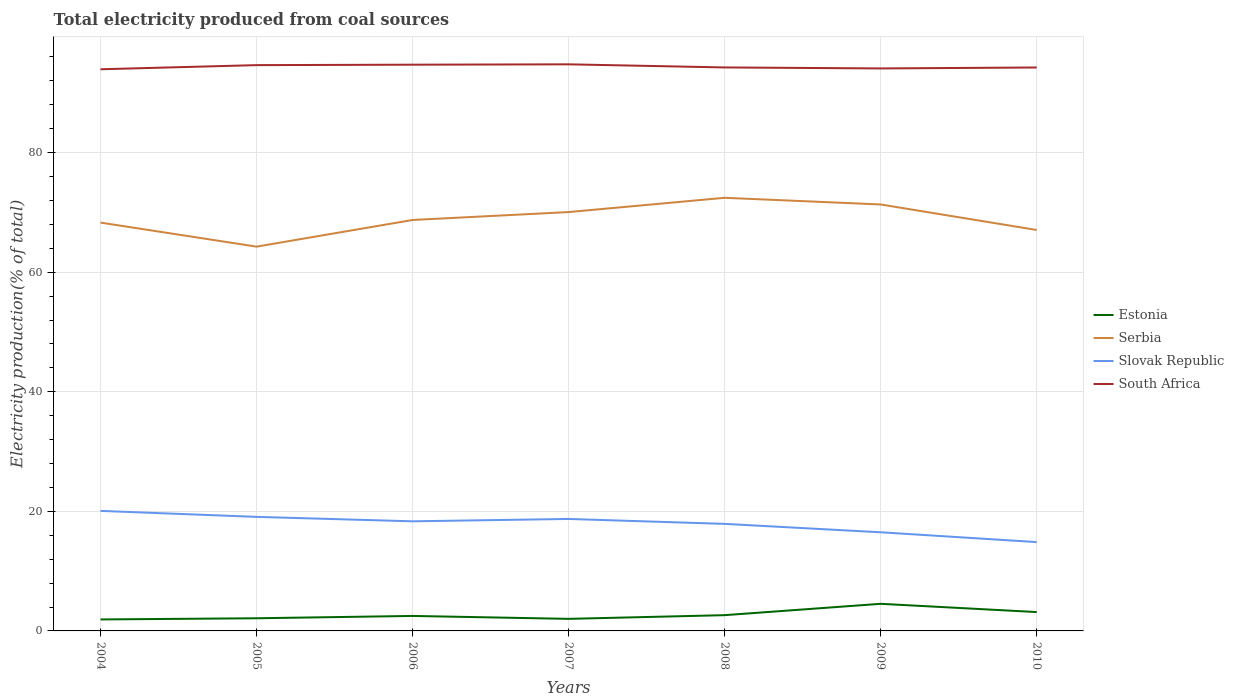How many different coloured lines are there?
Offer a very short reply. 4. Is the number of lines equal to the number of legend labels?
Your answer should be compact. Yes. Across all years, what is the maximum total electricity produced in Estonia?
Offer a terse response. 1.92. In which year was the total electricity produced in Slovak Republic maximum?
Make the answer very short. 2010. What is the total total electricity produced in Slovak Republic in the graph?
Make the answer very short. 1.35. What is the difference between the highest and the second highest total electricity produced in Slovak Republic?
Provide a succinct answer. 5.22. What is the difference between the highest and the lowest total electricity produced in Serbia?
Make the answer very short. 3. Is the total electricity produced in Serbia strictly greater than the total electricity produced in South Africa over the years?
Give a very brief answer. Yes. How many lines are there?
Make the answer very short. 4. How many years are there in the graph?
Ensure brevity in your answer.  7. Are the values on the major ticks of Y-axis written in scientific E-notation?
Your answer should be compact. No. Does the graph contain any zero values?
Make the answer very short. No. Where does the legend appear in the graph?
Offer a terse response. Center right. What is the title of the graph?
Ensure brevity in your answer.  Total electricity produced from coal sources. Does "Timor-Leste" appear as one of the legend labels in the graph?
Your response must be concise. No. What is the label or title of the X-axis?
Ensure brevity in your answer.  Years. What is the Electricity production(% of total) of Estonia in 2004?
Your answer should be very brief. 1.92. What is the Electricity production(% of total) of Serbia in 2004?
Your answer should be compact. 68.29. What is the Electricity production(% of total) of Slovak Republic in 2004?
Offer a very short reply. 20.08. What is the Electricity production(% of total) in South Africa in 2004?
Your response must be concise. 93.93. What is the Electricity production(% of total) in Estonia in 2005?
Provide a succinct answer. 2.12. What is the Electricity production(% of total) of Serbia in 2005?
Provide a succinct answer. 64.27. What is the Electricity production(% of total) of Slovak Republic in 2005?
Your answer should be very brief. 19.07. What is the Electricity production(% of total) in South Africa in 2005?
Give a very brief answer. 94.63. What is the Electricity production(% of total) in Estonia in 2006?
Your answer should be very brief. 2.51. What is the Electricity production(% of total) of Serbia in 2006?
Offer a terse response. 68.73. What is the Electricity production(% of total) in Slovak Republic in 2006?
Offer a terse response. 18.33. What is the Electricity production(% of total) in South Africa in 2006?
Provide a short and direct response. 94.7. What is the Electricity production(% of total) of Estonia in 2007?
Your response must be concise. 2.02. What is the Electricity production(% of total) of Serbia in 2007?
Keep it short and to the point. 70.05. What is the Electricity production(% of total) in Slovak Republic in 2007?
Ensure brevity in your answer.  18.73. What is the Electricity production(% of total) of South Africa in 2007?
Your answer should be very brief. 94.76. What is the Electricity production(% of total) in Estonia in 2008?
Give a very brief answer. 2.64. What is the Electricity production(% of total) of Serbia in 2008?
Keep it short and to the point. 72.44. What is the Electricity production(% of total) in Slovak Republic in 2008?
Provide a short and direct response. 17.9. What is the Electricity production(% of total) in South Africa in 2008?
Your answer should be compact. 94.24. What is the Electricity production(% of total) of Estonia in 2009?
Keep it short and to the point. 4.53. What is the Electricity production(% of total) in Serbia in 2009?
Provide a short and direct response. 71.32. What is the Electricity production(% of total) in Slovak Republic in 2009?
Your answer should be very brief. 16.5. What is the Electricity production(% of total) of South Africa in 2009?
Provide a succinct answer. 94.07. What is the Electricity production(% of total) of Estonia in 2010?
Your answer should be very brief. 3.15. What is the Electricity production(% of total) in Serbia in 2010?
Provide a succinct answer. 67.06. What is the Electricity production(% of total) of Slovak Republic in 2010?
Give a very brief answer. 14.86. What is the Electricity production(% of total) of South Africa in 2010?
Make the answer very short. 94.23. Across all years, what is the maximum Electricity production(% of total) in Estonia?
Give a very brief answer. 4.53. Across all years, what is the maximum Electricity production(% of total) of Serbia?
Your answer should be compact. 72.44. Across all years, what is the maximum Electricity production(% of total) in Slovak Republic?
Keep it short and to the point. 20.08. Across all years, what is the maximum Electricity production(% of total) of South Africa?
Your answer should be compact. 94.76. Across all years, what is the minimum Electricity production(% of total) in Estonia?
Offer a terse response. 1.92. Across all years, what is the minimum Electricity production(% of total) of Serbia?
Your response must be concise. 64.27. Across all years, what is the minimum Electricity production(% of total) of Slovak Republic?
Your response must be concise. 14.86. Across all years, what is the minimum Electricity production(% of total) of South Africa?
Your response must be concise. 93.93. What is the total Electricity production(% of total) in Estonia in the graph?
Offer a terse response. 18.89. What is the total Electricity production(% of total) in Serbia in the graph?
Provide a short and direct response. 482.16. What is the total Electricity production(% of total) of Slovak Republic in the graph?
Give a very brief answer. 125.46. What is the total Electricity production(% of total) in South Africa in the graph?
Ensure brevity in your answer.  660.56. What is the difference between the Electricity production(% of total) of Estonia in 2004 and that in 2005?
Ensure brevity in your answer.  -0.2. What is the difference between the Electricity production(% of total) of Serbia in 2004 and that in 2005?
Keep it short and to the point. 4.02. What is the difference between the Electricity production(% of total) in South Africa in 2004 and that in 2005?
Keep it short and to the point. -0.69. What is the difference between the Electricity production(% of total) of Estonia in 2004 and that in 2006?
Your answer should be very brief. -0.59. What is the difference between the Electricity production(% of total) in Serbia in 2004 and that in 2006?
Ensure brevity in your answer.  -0.44. What is the difference between the Electricity production(% of total) of Slovak Republic in 2004 and that in 2006?
Offer a very short reply. 1.74. What is the difference between the Electricity production(% of total) of South Africa in 2004 and that in 2006?
Ensure brevity in your answer.  -0.77. What is the difference between the Electricity production(% of total) of Estonia in 2004 and that in 2007?
Keep it short and to the point. -0.1. What is the difference between the Electricity production(% of total) of Serbia in 2004 and that in 2007?
Ensure brevity in your answer.  -1.76. What is the difference between the Electricity production(% of total) of Slovak Republic in 2004 and that in 2007?
Ensure brevity in your answer.  1.35. What is the difference between the Electricity production(% of total) in South Africa in 2004 and that in 2007?
Offer a terse response. -0.83. What is the difference between the Electricity production(% of total) in Estonia in 2004 and that in 2008?
Make the answer very short. -0.72. What is the difference between the Electricity production(% of total) of Serbia in 2004 and that in 2008?
Give a very brief answer. -4.15. What is the difference between the Electricity production(% of total) in Slovak Republic in 2004 and that in 2008?
Offer a terse response. 2.17. What is the difference between the Electricity production(% of total) in South Africa in 2004 and that in 2008?
Your answer should be very brief. -0.31. What is the difference between the Electricity production(% of total) in Estonia in 2004 and that in 2009?
Provide a short and direct response. -2.61. What is the difference between the Electricity production(% of total) of Serbia in 2004 and that in 2009?
Offer a very short reply. -3.03. What is the difference between the Electricity production(% of total) of Slovak Republic in 2004 and that in 2009?
Offer a very short reply. 3.58. What is the difference between the Electricity production(% of total) in South Africa in 2004 and that in 2009?
Provide a short and direct response. -0.14. What is the difference between the Electricity production(% of total) of Estonia in 2004 and that in 2010?
Make the answer very short. -1.23. What is the difference between the Electricity production(% of total) of Serbia in 2004 and that in 2010?
Give a very brief answer. 1.24. What is the difference between the Electricity production(% of total) in Slovak Republic in 2004 and that in 2010?
Offer a very short reply. 5.22. What is the difference between the Electricity production(% of total) of South Africa in 2004 and that in 2010?
Your response must be concise. -0.3. What is the difference between the Electricity production(% of total) of Estonia in 2005 and that in 2006?
Provide a succinct answer. -0.39. What is the difference between the Electricity production(% of total) of Serbia in 2005 and that in 2006?
Provide a succinct answer. -4.46. What is the difference between the Electricity production(% of total) of Slovak Republic in 2005 and that in 2006?
Your answer should be compact. 0.74. What is the difference between the Electricity production(% of total) in South Africa in 2005 and that in 2006?
Offer a terse response. -0.07. What is the difference between the Electricity production(% of total) of Estonia in 2005 and that in 2007?
Offer a terse response. 0.1. What is the difference between the Electricity production(% of total) in Serbia in 2005 and that in 2007?
Offer a terse response. -5.78. What is the difference between the Electricity production(% of total) of Slovak Republic in 2005 and that in 2007?
Your answer should be very brief. 0.35. What is the difference between the Electricity production(% of total) of South Africa in 2005 and that in 2007?
Your response must be concise. -0.13. What is the difference between the Electricity production(% of total) of Estonia in 2005 and that in 2008?
Your answer should be very brief. -0.52. What is the difference between the Electricity production(% of total) of Serbia in 2005 and that in 2008?
Offer a very short reply. -8.17. What is the difference between the Electricity production(% of total) of Slovak Republic in 2005 and that in 2008?
Make the answer very short. 1.17. What is the difference between the Electricity production(% of total) in South Africa in 2005 and that in 2008?
Keep it short and to the point. 0.39. What is the difference between the Electricity production(% of total) of Estonia in 2005 and that in 2009?
Offer a very short reply. -2.42. What is the difference between the Electricity production(% of total) in Serbia in 2005 and that in 2009?
Your response must be concise. -7.05. What is the difference between the Electricity production(% of total) in Slovak Republic in 2005 and that in 2009?
Provide a short and direct response. 2.58. What is the difference between the Electricity production(% of total) of South Africa in 2005 and that in 2009?
Offer a very short reply. 0.55. What is the difference between the Electricity production(% of total) in Estonia in 2005 and that in 2010?
Your response must be concise. -1.04. What is the difference between the Electricity production(% of total) in Serbia in 2005 and that in 2010?
Give a very brief answer. -2.78. What is the difference between the Electricity production(% of total) of Slovak Republic in 2005 and that in 2010?
Offer a very short reply. 4.22. What is the difference between the Electricity production(% of total) of South Africa in 2005 and that in 2010?
Provide a short and direct response. 0.4. What is the difference between the Electricity production(% of total) in Estonia in 2006 and that in 2007?
Provide a succinct answer. 0.49. What is the difference between the Electricity production(% of total) in Serbia in 2006 and that in 2007?
Ensure brevity in your answer.  -1.32. What is the difference between the Electricity production(% of total) of Slovak Republic in 2006 and that in 2007?
Keep it short and to the point. -0.39. What is the difference between the Electricity production(% of total) of South Africa in 2006 and that in 2007?
Keep it short and to the point. -0.06. What is the difference between the Electricity production(% of total) of Estonia in 2006 and that in 2008?
Offer a terse response. -0.13. What is the difference between the Electricity production(% of total) of Serbia in 2006 and that in 2008?
Offer a terse response. -3.71. What is the difference between the Electricity production(% of total) in Slovak Republic in 2006 and that in 2008?
Keep it short and to the point. 0.43. What is the difference between the Electricity production(% of total) in South Africa in 2006 and that in 2008?
Give a very brief answer. 0.46. What is the difference between the Electricity production(% of total) of Estonia in 2006 and that in 2009?
Offer a terse response. -2.03. What is the difference between the Electricity production(% of total) of Serbia in 2006 and that in 2009?
Ensure brevity in your answer.  -2.59. What is the difference between the Electricity production(% of total) of Slovak Republic in 2006 and that in 2009?
Provide a succinct answer. 1.83. What is the difference between the Electricity production(% of total) of South Africa in 2006 and that in 2009?
Offer a very short reply. 0.63. What is the difference between the Electricity production(% of total) in Estonia in 2006 and that in 2010?
Your response must be concise. -0.65. What is the difference between the Electricity production(% of total) of Serbia in 2006 and that in 2010?
Make the answer very short. 1.67. What is the difference between the Electricity production(% of total) of Slovak Republic in 2006 and that in 2010?
Provide a succinct answer. 3.48. What is the difference between the Electricity production(% of total) of South Africa in 2006 and that in 2010?
Make the answer very short. 0.47. What is the difference between the Electricity production(% of total) in Estonia in 2007 and that in 2008?
Give a very brief answer. -0.62. What is the difference between the Electricity production(% of total) in Serbia in 2007 and that in 2008?
Your answer should be compact. -2.39. What is the difference between the Electricity production(% of total) in Slovak Republic in 2007 and that in 2008?
Keep it short and to the point. 0.82. What is the difference between the Electricity production(% of total) of South Africa in 2007 and that in 2008?
Your answer should be very brief. 0.52. What is the difference between the Electricity production(% of total) in Estonia in 2007 and that in 2009?
Provide a succinct answer. -2.52. What is the difference between the Electricity production(% of total) of Serbia in 2007 and that in 2009?
Your answer should be very brief. -1.27. What is the difference between the Electricity production(% of total) of Slovak Republic in 2007 and that in 2009?
Give a very brief answer. 2.23. What is the difference between the Electricity production(% of total) in South Africa in 2007 and that in 2009?
Provide a succinct answer. 0.69. What is the difference between the Electricity production(% of total) of Estonia in 2007 and that in 2010?
Your answer should be very brief. -1.14. What is the difference between the Electricity production(% of total) of Serbia in 2007 and that in 2010?
Ensure brevity in your answer.  3. What is the difference between the Electricity production(% of total) in Slovak Republic in 2007 and that in 2010?
Provide a short and direct response. 3.87. What is the difference between the Electricity production(% of total) of South Africa in 2007 and that in 2010?
Give a very brief answer. 0.53. What is the difference between the Electricity production(% of total) in Estonia in 2008 and that in 2009?
Give a very brief answer. -1.9. What is the difference between the Electricity production(% of total) of Serbia in 2008 and that in 2009?
Your answer should be very brief. 1.12. What is the difference between the Electricity production(% of total) in Slovak Republic in 2008 and that in 2009?
Offer a very short reply. 1.41. What is the difference between the Electricity production(% of total) of South Africa in 2008 and that in 2009?
Provide a succinct answer. 0.17. What is the difference between the Electricity production(% of total) of Estonia in 2008 and that in 2010?
Give a very brief answer. -0.52. What is the difference between the Electricity production(% of total) in Serbia in 2008 and that in 2010?
Keep it short and to the point. 5.38. What is the difference between the Electricity production(% of total) of Slovak Republic in 2008 and that in 2010?
Keep it short and to the point. 3.05. What is the difference between the Electricity production(% of total) in South Africa in 2008 and that in 2010?
Give a very brief answer. 0.01. What is the difference between the Electricity production(% of total) of Estonia in 2009 and that in 2010?
Make the answer very short. 1.38. What is the difference between the Electricity production(% of total) in Serbia in 2009 and that in 2010?
Your response must be concise. 4.27. What is the difference between the Electricity production(% of total) of Slovak Republic in 2009 and that in 2010?
Provide a short and direct response. 1.64. What is the difference between the Electricity production(% of total) in South Africa in 2009 and that in 2010?
Ensure brevity in your answer.  -0.16. What is the difference between the Electricity production(% of total) in Estonia in 2004 and the Electricity production(% of total) in Serbia in 2005?
Provide a short and direct response. -62.35. What is the difference between the Electricity production(% of total) of Estonia in 2004 and the Electricity production(% of total) of Slovak Republic in 2005?
Provide a short and direct response. -17.15. What is the difference between the Electricity production(% of total) in Estonia in 2004 and the Electricity production(% of total) in South Africa in 2005?
Your answer should be compact. -92.7. What is the difference between the Electricity production(% of total) in Serbia in 2004 and the Electricity production(% of total) in Slovak Republic in 2005?
Offer a terse response. 49.22. What is the difference between the Electricity production(% of total) in Serbia in 2004 and the Electricity production(% of total) in South Africa in 2005?
Offer a terse response. -26.34. What is the difference between the Electricity production(% of total) of Slovak Republic in 2004 and the Electricity production(% of total) of South Africa in 2005?
Your response must be concise. -74.55. What is the difference between the Electricity production(% of total) of Estonia in 2004 and the Electricity production(% of total) of Serbia in 2006?
Your answer should be compact. -66.81. What is the difference between the Electricity production(% of total) in Estonia in 2004 and the Electricity production(% of total) in Slovak Republic in 2006?
Make the answer very short. -16.41. What is the difference between the Electricity production(% of total) of Estonia in 2004 and the Electricity production(% of total) of South Africa in 2006?
Ensure brevity in your answer.  -92.78. What is the difference between the Electricity production(% of total) of Serbia in 2004 and the Electricity production(% of total) of Slovak Republic in 2006?
Keep it short and to the point. 49.96. What is the difference between the Electricity production(% of total) of Serbia in 2004 and the Electricity production(% of total) of South Africa in 2006?
Keep it short and to the point. -26.41. What is the difference between the Electricity production(% of total) of Slovak Republic in 2004 and the Electricity production(% of total) of South Africa in 2006?
Ensure brevity in your answer.  -74.62. What is the difference between the Electricity production(% of total) of Estonia in 2004 and the Electricity production(% of total) of Serbia in 2007?
Ensure brevity in your answer.  -68.13. What is the difference between the Electricity production(% of total) in Estonia in 2004 and the Electricity production(% of total) in Slovak Republic in 2007?
Keep it short and to the point. -16.8. What is the difference between the Electricity production(% of total) in Estonia in 2004 and the Electricity production(% of total) in South Africa in 2007?
Provide a succinct answer. -92.84. What is the difference between the Electricity production(% of total) in Serbia in 2004 and the Electricity production(% of total) in Slovak Republic in 2007?
Your response must be concise. 49.56. What is the difference between the Electricity production(% of total) of Serbia in 2004 and the Electricity production(% of total) of South Africa in 2007?
Keep it short and to the point. -26.47. What is the difference between the Electricity production(% of total) in Slovak Republic in 2004 and the Electricity production(% of total) in South Africa in 2007?
Your answer should be very brief. -74.68. What is the difference between the Electricity production(% of total) in Estonia in 2004 and the Electricity production(% of total) in Serbia in 2008?
Your answer should be very brief. -70.52. What is the difference between the Electricity production(% of total) of Estonia in 2004 and the Electricity production(% of total) of Slovak Republic in 2008?
Ensure brevity in your answer.  -15.98. What is the difference between the Electricity production(% of total) in Estonia in 2004 and the Electricity production(% of total) in South Africa in 2008?
Offer a very short reply. -92.32. What is the difference between the Electricity production(% of total) of Serbia in 2004 and the Electricity production(% of total) of Slovak Republic in 2008?
Your answer should be very brief. 50.39. What is the difference between the Electricity production(% of total) of Serbia in 2004 and the Electricity production(% of total) of South Africa in 2008?
Your answer should be compact. -25.95. What is the difference between the Electricity production(% of total) of Slovak Republic in 2004 and the Electricity production(% of total) of South Africa in 2008?
Keep it short and to the point. -74.16. What is the difference between the Electricity production(% of total) in Estonia in 2004 and the Electricity production(% of total) in Serbia in 2009?
Keep it short and to the point. -69.4. What is the difference between the Electricity production(% of total) in Estonia in 2004 and the Electricity production(% of total) in Slovak Republic in 2009?
Provide a short and direct response. -14.58. What is the difference between the Electricity production(% of total) in Estonia in 2004 and the Electricity production(% of total) in South Africa in 2009?
Make the answer very short. -92.15. What is the difference between the Electricity production(% of total) of Serbia in 2004 and the Electricity production(% of total) of Slovak Republic in 2009?
Ensure brevity in your answer.  51.79. What is the difference between the Electricity production(% of total) of Serbia in 2004 and the Electricity production(% of total) of South Africa in 2009?
Provide a succinct answer. -25.78. What is the difference between the Electricity production(% of total) of Slovak Republic in 2004 and the Electricity production(% of total) of South Africa in 2009?
Give a very brief answer. -74. What is the difference between the Electricity production(% of total) in Estonia in 2004 and the Electricity production(% of total) in Serbia in 2010?
Give a very brief answer. -65.13. What is the difference between the Electricity production(% of total) of Estonia in 2004 and the Electricity production(% of total) of Slovak Republic in 2010?
Offer a very short reply. -12.93. What is the difference between the Electricity production(% of total) in Estonia in 2004 and the Electricity production(% of total) in South Africa in 2010?
Your response must be concise. -92.31. What is the difference between the Electricity production(% of total) of Serbia in 2004 and the Electricity production(% of total) of Slovak Republic in 2010?
Make the answer very short. 53.43. What is the difference between the Electricity production(% of total) in Serbia in 2004 and the Electricity production(% of total) in South Africa in 2010?
Your answer should be compact. -25.94. What is the difference between the Electricity production(% of total) of Slovak Republic in 2004 and the Electricity production(% of total) of South Africa in 2010?
Your answer should be very brief. -74.16. What is the difference between the Electricity production(% of total) in Estonia in 2005 and the Electricity production(% of total) in Serbia in 2006?
Provide a short and direct response. -66.61. What is the difference between the Electricity production(% of total) of Estonia in 2005 and the Electricity production(% of total) of Slovak Republic in 2006?
Ensure brevity in your answer.  -16.22. What is the difference between the Electricity production(% of total) of Estonia in 2005 and the Electricity production(% of total) of South Africa in 2006?
Ensure brevity in your answer.  -92.58. What is the difference between the Electricity production(% of total) of Serbia in 2005 and the Electricity production(% of total) of Slovak Republic in 2006?
Your response must be concise. 45.94. What is the difference between the Electricity production(% of total) of Serbia in 2005 and the Electricity production(% of total) of South Africa in 2006?
Provide a succinct answer. -30.43. What is the difference between the Electricity production(% of total) of Slovak Republic in 2005 and the Electricity production(% of total) of South Africa in 2006?
Offer a terse response. -75.63. What is the difference between the Electricity production(% of total) in Estonia in 2005 and the Electricity production(% of total) in Serbia in 2007?
Ensure brevity in your answer.  -67.94. What is the difference between the Electricity production(% of total) in Estonia in 2005 and the Electricity production(% of total) in Slovak Republic in 2007?
Make the answer very short. -16.61. What is the difference between the Electricity production(% of total) in Estonia in 2005 and the Electricity production(% of total) in South Africa in 2007?
Give a very brief answer. -92.64. What is the difference between the Electricity production(% of total) of Serbia in 2005 and the Electricity production(% of total) of Slovak Republic in 2007?
Keep it short and to the point. 45.54. What is the difference between the Electricity production(% of total) in Serbia in 2005 and the Electricity production(% of total) in South Africa in 2007?
Keep it short and to the point. -30.49. What is the difference between the Electricity production(% of total) in Slovak Republic in 2005 and the Electricity production(% of total) in South Africa in 2007?
Your answer should be very brief. -75.69. What is the difference between the Electricity production(% of total) of Estonia in 2005 and the Electricity production(% of total) of Serbia in 2008?
Provide a short and direct response. -70.32. What is the difference between the Electricity production(% of total) of Estonia in 2005 and the Electricity production(% of total) of Slovak Republic in 2008?
Keep it short and to the point. -15.79. What is the difference between the Electricity production(% of total) in Estonia in 2005 and the Electricity production(% of total) in South Africa in 2008?
Your response must be concise. -92.12. What is the difference between the Electricity production(% of total) in Serbia in 2005 and the Electricity production(% of total) in Slovak Republic in 2008?
Give a very brief answer. 46.37. What is the difference between the Electricity production(% of total) of Serbia in 2005 and the Electricity production(% of total) of South Africa in 2008?
Provide a short and direct response. -29.97. What is the difference between the Electricity production(% of total) of Slovak Republic in 2005 and the Electricity production(% of total) of South Africa in 2008?
Your answer should be very brief. -75.17. What is the difference between the Electricity production(% of total) of Estonia in 2005 and the Electricity production(% of total) of Serbia in 2009?
Your answer should be compact. -69.21. What is the difference between the Electricity production(% of total) in Estonia in 2005 and the Electricity production(% of total) in Slovak Republic in 2009?
Make the answer very short. -14.38. What is the difference between the Electricity production(% of total) in Estonia in 2005 and the Electricity production(% of total) in South Africa in 2009?
Make the answer very short. -91.96. What is the difference between the Electricity production(% of total) of Serbia in 2005 and the Electricity production(% of total) of Slovak Republic in 2009?
Ensure brevity in your answer.  47.77. What is the difference between the Electricity production(% of total) in Serbia in 2005 and the Electricity production(% of total) in South Africa in 2009?
Provide a succinct answer. -29.8. What is the difference between the Electricity production(% of total) in Slovak Republic in 2005 and the Electricity production(% of total) in South Africa in 2009?
Your answer should be very brief. -75. What is the difference between the Electricity production(% of total) in Estonia in 2005 and the Electricity production(% of total) in Serbia in 2010?
Ensure brevity in your answer.  -64.94. What is the difference between the Electricity production(% of total) of Estonia in 2005 and the Electricity production(% of total) of Slovak Republic in 2010?
Offer a very short reply. -12.74. What is the difference between the Electricity production(% of total) of Estonia in 2005 and the Electricity production(% of total) of South Africa in 2010?
Your response must be concise. -92.11. What is the difference between the Electricity production(% of total) of Serbia in 2005 and the Electricity production(% of total) of Slovak Republic in 2010?
Your response must be concise. 49.41. What is the difference between the Electricity production(% of total) in Serbia in 2005 and the Electricity production(% of total) in South Africa in 2010?
Give a very brief answer. -29.96. What is the difference between the Electricity production(% of total) in Slovak Republic in 2005 and the Electricity production(% of total) in South Africa in 2010?
Offer a very short reply. -75.16. What is the difference between the Electricity production(% of total) of Estonia in 2006 and the Electricity production(% of total) of Serbia in 2007?
Keep it short and to the point. -67.54. What is the difference between the Electricity production(% of total) in Estonia in 2006 and the Electricity production(% of total) in Slovak Republic in 2007?
Your answer should be very brief. -16.22. What is the difference between the Electricity production(% of total) in Estonia in 2006 and the Electricity production(% of total) in South Africa in 2007?
Give a very brief answer. -92.25. What is the difference between the Electricity production(% of total) in Serbia in 2006 and the Electricity production(% of total) in Slovak Republic in 2007?
Provide a short and direct response. 50. What is the difference between the Electricity production(% of total) in Serbia in 2006 and the Electricity production(% of total) in South Africa in 2007?
Your response must be concise. -26.03. What is the difference between the Electricity production(% of total) of Slovak Republic in 2006 and the Electricity production(% of total) of South Africa in 2007?
Provide a succinct answer. -76.43. What is the difference between the Electricity production(% of total) in Estonia in 2006 and the Electricity production(% of total) in Serbia in 2008?
Provide a succinct answer. -69.93. What is the difference between the Electricity production(% of total) in Estonia in 2006 and the Electricity production(% of total) in Slovak Republic in 2008?
Offer a very short reply. -15.4. What is the difference between the Electricity production(% of total) of Estonia in 2006 and the Electricity production(% of total) of South Africa in 2008?
Keep it short and to the point. -91.73. What is the difference between the Electricity production(% of total) in Serbia in 2006 and the Electricity production(% of total) in Slovak Republic in 2008?
Give a very brief answer. 50.83. What is the difference between the Electricity production(% of total) in Serbia in 2006 and the Electricity production(% of total) in South Africa in 2008?
Ensure brevity in your answer.  -25.51. What is the difference between the Electricity production(% of total) in Slovak Republic in 2006 and the Electricity production(% of total) in South Africa in 2008?
Your response must be concise. -75.91. What is the difference between the Electricity production(% of total) in Estonia in 2006 and the Electricity production(% of total) in Serbia in 2009?
Ensure brevity in your answer.  -68.81. What is the difference between the Electricity production(% of total) in Estonia in 2006 and the Electricity production(% of total) in Slovak Republic in 2009?
Ensure brevity in your answer.  -13.99. What is the difference between the Electricity production(% of total) in Estonia in 2006 and the Electricity production(% of total) in South Africa in 2009?
Give a very brief answer. -91.57. What is the difference between the Electricity production(% of total) of Serbia in 2006 and the Electricity production(% of total) of Slovak Republic in 2009?
Your answer should be compact. 52.23. What is the difference between the Electricity production(% of total) in Serbia in 2006 and the Electricity production(% of total) in South Africa in 2009?
Provide a succinct answer. -25.34. What is the difference between the Electricity production(% of total) of Slovak Republic in 2006 and the Electricity production(% of total) of South Africa in 2009?
Your answer should be very brief. -75.74. What is the difference between the Electricity production(% of total) in Estonia in 2006 and the Electricity production(% of total) in Serbia in 2010?
Your response must be concise. -64.55. What is the difference between the Electricity production(% of total) in Estonia in 2006 and the Electricity production(% of total) in Slovak Republic in 2010?
Your answer should be compact. -12.35. What is the difference between the Electricity production(% of total) in Estonia in 2006 and the Electricity production(% of total) in South Africa in 2010?
Give a very brief answer. -91.72. What is the difference between the Electricity production(% of total) of Serbia in 2006 and the Electricity production(% of total) of Slovak Republic in 2010?
Provide a succinct answer. 53.87. What is the difference between the Electricity production(% of total) in Serbia in 2006 and the Electricity production(% of total) in South Africa in 2010?
Provide a succinct answer. -25.5. What is the difference between the Electricity production(% of total) in Slovak Republic in 2006 and the Electricity production(% of total) in South Africa in 2010?
Your response must be concise. -75.9. What is the difference between the Electricity production(% of total) in Estonia in 2007 and the Electricity production(% of total) in Serbia in 2008?
Give a very brief answer. -70.42. What is the difference between the Electricity production(% of total) of Estonia in 2007 and the Electricity production(% of total) of Slovak Republic in 2008?
Your response must be concise. -15.89. What is the difference between the Electricity production(% of total) in Estonia in 2007 and the Electricity production(% of total) in South Africa in 2008?
Make the answer very short. -92.22. What is the difference between the Electricity production(% of total) in Serbia in 2007 and the Electricity production(% of total) in Slovak Republic in 2008?
Your response must be concise. 52.15. What is the difference between the Electricity production(% of total) in Serbia in 2007 and the Electricity production(% of total) in South Africa in 2008?
Make the answer very short. -24.19. What is the difference between the Electricity production(% of total) in Slovak Republic in 2007 and the Electricity production(% of total) in South Africa in 2008?
Keep it short and to the point. -75.51. What is the difference between the Electricity production(% of total) in Estonia in 2007 and the Electricity production(% of total) in Serbia in 2009?
Provide a succinct answer. -69.3. What is the difference between the Electricity production(% of total) in Estonia in 2007 and the Electricity production(% of total) in Slovak Republic in 2009?
Your answer should be compact. -14.48. What is the difference between the Electricity production(% of total) in Estonia in 2007 and the Electricity production(% of total) in South Africa in 2009?
Your answer should be very brief. -92.06. What is the difference between the Electricity production(% of total) of Serbia in 2007 and the Electricity production(% of total) of Slovak Republic in 2009?
Your answer should be compact. 53.55. What is the difference between the Electricity production(% of total) in Serbia in 2007 and the Electricity production(% of total) in South Africa in 2009?
Offer a terse response. -24.02. What is the difference between the Electricity production(% of total) of Slovak Republic in 2007 and the Electricity production(% of total) of South Africa in 2009?
Provide a succinct answer. -75.35. What is the difference between the Electricity production(% of total) in Estonia in 2007 and the Electricity production(% of total) in Serbia in 2010?
Provide a succinct answer. -65.04. What is the difference between the Electricity production(% of total) of Estonia in 2007 and the Electricity production(% of total) of Slovak Republic in 2010?
Keep it short and to the point. -12.84. What is the difference between the Electricity production(% of total) of Estonia in 2007 and the Electricity production(% of total) of South Africa in 2010?
Keep it short and to the point. -92.21. What is the difference between the Electricity production(% of total) in Serbia in 2007 and the Electricity production(% of total) in Slovak Republic in 2010?
Keep it short and to the point. 55.2. What is the difference between the Electricity production(% of total) of Serbia in 2007 and the Electricity production(% of total) of South Africa in 2010?
Provide a succinct answer. -24.18. What is the difference between the Electricity production(% of total) in Slovak Republic in 2007 and the Electricity production(% of total) in South Africa in 2010?
Provide a succinct answer. -75.51. What is the difference between the Electricity production(% of total) of Estonia in 2008 and the Electricity production(% of total) of Serbia in 2009?
Keep it short and to the point. -68.69. What is the difference between the Electricity production(% of total) of Estonia in 2008 and the Electricity production(% of total) of Slovak Republic in 2009?
Provide a succinct answer. -13.86. What is the difference between the Electricity production(% of total) of Estonia in 2008 and the Electricity production(% of total) of South Africa in 2009?
Make the answer very short. -91.44. What is the difference between the Electricity production(% of total) in Serbia in 2008 and the Electricity production(% of total) in Slovak Republic in 2009?
Ensure brevity in your answer.  55.94. What is the difference between the Electricity production(% of total) of Serbia in 2008 and the Electricity production(% of total) of South Africa in 2009?
Your answer should be very brief. -21.63. What is the difference between the Electricity production(% of total) of Slovak Republic in 2008 and the Electricity production(% of total) of South Africa in 2009?
Offer a terse response. -76.17. What is the difference between the Electricity production(% of total) in Estonia in 2008 and the Electricity production(% of total) in Serbia in 2010?
Your answer should be compact. -64.42. What is the difference between the Electricity production(% of total) of Estonia in 2008 and the Electricity production(% of total) of Slovak Republic in 2010?
Your answer should be very brief. -12.22. What is the difference between the Electricity production(% of total) of Estonia in 2008 and the Electricity production(% of total) of South Africa in 2010?
Your response must be concise. -91.59. What is the difference between the Electricity production(% of total) of Serbia in 2008 and the Electricity production(% of total) of Slovak Republic in 2010?
Your answer should be very brief. 57.58. What is the difference between the Electricity production(% of total) in Serbia in 2008 and the Electricity production(% of total) in South Africa in 2010?
Ensure brevity in your answer.  -21.79. What is the difference between the Electricity production(% of total) of Slovak Republic in 2008 and the Electricity production(% of total) of South Africa in 2010?
Offer a very short reply. -76.33. What is the difference between the Electricity production(% of total) of Estonia in 2009 and the Electricity production(% of total) of Serbia in 2010?
Your answer should be compact. -62.52. What is the difference between the Electricity production(% of total) of Estonia in 2009 and the Electricity production(% of total) of Slovak Republic in 2010?
Your response must be concise. -10.32. What is the difference between the Electricity production(% of total) in Estonia in 2009 and the Electricity production(% of total) in South Africa in 2010?
Provide a short and direct response. -89.7. What is the difference between the Electricity production(% of total) in Serbia in 2009 and the Electricity production(% of total) in Slovak Republic in 2010?
Your answer should be compact. 56.47. What is the difference between the Electricity production(% of total) in Serbia in 2009 and the Electricity production(% of total) in South Africa in 2010?
Your answer should be very brief. -22.91. What is the difference between the Electricity production(% of total) of Slovak Republic in 2009 and the Electricity production(% of total) of South Africa in 2010?
Give a very brief answer. -77.73. What is the average Electricity production(% of total) of Estonia per year?
Your answer should be very brief. 2.7. What is the average Electricity production(% of total) of Serbia per year?
Make the answer very short. 68.88. What is the average Electricity production(% of total) in Slovak Republic per year?
Make the answer very short. 17.92. What is the average Electricity production(% of total) of South Africa per year?
Provide a short and direct response. 94.37. In the year 2004, what is the difference between the Electricity production(% of total) in Estonia and Electricity production(% of total) in Serbia?
Provide a succinct answer. -66.37. In the year 2004, what is the difference between the Electricity production(% of total) of Estonia and Electricity production(% of total) of Slovak Republic?
Your answer should be compact. -18.15. In the year 2004, what is the difference between the Electricity production(% of total) in Estonia and Electricity production(% of total) in South Africa?
Offer a very short reply. -92.01. In the year 2004, what is the difference between the Electricity production(% of total) in Serbia and Electricity production(% of total) in Slovak Republic?
Make the answer very short. 48.22. In the year 2004, what is the difference between the Electricity production(% of total) in Serbia and Electricity production(% of total) in South Africa?
Your answer should be compact. -25.64. In the year 2004, what is the difference between the Electricity production(% of total) in Slovak Republic and Electricity production(% of total) in South Africa?
Your answer should be very brief. -73.86. In the year 2005, what is the difference between the Electricity production(% of total) in Estonia and Electricity production(% of total) in Serbia?
Give a very brief answer. -62.15. In the year 2005, what is the difference between the Electricity production(% of total) of Estonia and Electricity production(% of total) of Slovak Republic?
Give a very brief answer. -16.96. In the year 2005, what is the difference between the Electricity production(% of total) in Estonia and Electricity production(% of total) in South Africa?
Your response must be concise. -92.51. In the year 2005, what is the difference between the Electricity production(% of total) of Serbia and Electricity production(% of total) of Slovak Republic?
Give a very brief answer. 45.2. In the year 2005, what is the difference between the Electricity production(% of total) of Serbia and Electricity production(% of total) of South Africa?
Your response must be concise. -30.36. In the year 2005, what is the difference between the Electricity production(% of total) in Slovak Republic and Electricity production(% of total) in South Africa?
Your answer should be compact. -75.55. In the year 2006, what is the difference between the Electricity production(% of total) of Estonia and Electricity production(% of total) of Serbia?
Provide a succinct answer. -66.22. In the year 2006, what is the difference between the Electricity production(% of total) in Estonia and Electricity production(% of total) in Slovak Republic?
Your answer should be compact. -15.82. In the year 2006, what is the difference between the Electricity production(% of total) of Estonia and Electricity production(% of total) of South Africa?
Your answer should be very brief. -92.19. In the year 2006, what is the difference between the Electricity production(% of total) in Serbia and Electricity production(% of total) in Slovak Republic?
Your answer should be very brief. 50.4. In the year 2006, what is the difference between the Electricity production(% of total) of Serbia and Electricity production(% of total) of South Africa?
Make the answer very short. -25.97. In the year 2006, what is the difference between the Electricity production(% of total) in Slovak Republic and Electricity production(% of total) in South Africa?
Provide a succinct answer. -76.37. In the year 2007, what is the difference between the Electricity production(% of total) of Estonia and Electricity production(% of total) of Serbia?
Keep it short and to the point. -68.03. In the year 2007, what is the difference between the Electricity production(% of total) in Estonia and Electricity production(% of total) in Slovak Republic?
Give a very brief answer. -16.71. In the year 2007, what is the difference between the Electricity production(% of total) of Estonia and Electricity production(% of total) of South Africa?
Your answer should be compact. -92.74. In the year 2007, what is the difference between the Electricity production(% of total) of Serbia and Electricity production(% of total) of Slovak Republic?
Give a very brief answer. 51.33. In the year 2007, what is the difference between the Electricity production(% of total) in Serbia and Electricity production(% of total) in South Africa?
Give a very brief answer. -24.71. In the year 2007, what is the difference between the Electricity production(% of total) of Slovak Republic and Electricity production(% of total) of South Africa?
Your answer should be very brief. -76.03. In the year 2008, what is the difference between the Electricity production(% of total) of Estonia and Electricity production(% of total) of Serbia?
Give a very brief answer. -69.8. In the year 2008, what is the difference between the Electricity production(% of total) in Estonia and Electricity production(% of total) in Slovak Republic?
Offer a very short reply. -15.27. In the year 2008, what is the difference between the Electricity production(% of total) of Estonia and Electricity production(% of total) of South Africa?
Your response must be concise. -91.6. In the year 2008, what is the difference between the Electricity production(% of total) in Serbia and Electricity production(% of total) in Slovak Republic?
Your response must be concise. 54.54. In the year 2008, what is the difference between the Electricity production(% of total) in Serbia and Electricity production(% of total) in South Africa?
Your answer should be very brief. -21.8. In the year 2008, what is the difference between the Electricity production(% of total) of Slovak Republic and Electricity production(% of total) of South Africa?
Offer a terse response. -76.34. In the year 2009, what is the difference between the Electricity production(% of total) in Estonia and Electricity production(% of total) in Serbia?
Provide a succinct answer. -66.79. In the year 2009, what is the difference between the Electricity production(% of total) of Estonia and Electricity production(% of total) of Slovak Republic?
Make the answer very short. -11.96. In the year 2009, what is the difference between the Electricity production(% of total) of Estonia and Electricity production(% of total) of South Africa?
Your answer should be compact. -89.54. In the year 2009, what is the difference between the Electricity production(% of total) of Serbia and Electricity production(% of total) of Slovak Republic?
Ensure brevity in your answer.  54.82. In the year 2009, what is the difference between the Electricity production(% of total) of Serbia and Electricity production(% of total) of South Africa?
Offer a very short reply. -22.75. In the year 2009, what is the difference between the Electricity production(% of total) in Slovak Republic and Electricity production(% of total) in South Africa?
Keep it short and to the point. -77.58. In the year 2010, what is the difference between the Electricity production(% of total) in Estonia and Electricity production(% of total) in Serbia?
Offer a terse response. -63.9. In the year 2010, what is the difference between the Electricity production(% of total) of Estonia and Electricity production(% of total) of Slovak Republic?
Provide a succinct answer. -11.7. In the year 2010, what is the difference between the Electricity production(% of total) in Estonia and Electricity production(% of total) in South Africa?
Give a very brief answer. -91.08. In the year 2010, what is the difference between the Electricity production(% of total) in Serbia and Electricity production(% of total) in Slovak Republic?
Your answer should be compact. 52.2. In the year 2010, what is the difference between the Electricity production(% of total) in Serbia and Electricity production(% of total) in South Africa?
Ensure brevity in your answer.  -27.18. In the year 2010, what is the difference between the Electricity production(% of total) of Slovak Republic and Electricity production(% of total) of South Africa?
Provide a short and direct response. -79.38. What is the ratio of the Electricity production(% of total) in Estonia in 2004 to that in 2005?
Offer a very short reply. 0.91. What is the ratio of the Electricity production(% of total) of Serbia in 2004 to that in 2005?
Your response must be concise. 1.06. What is the ratio of the Electricity production(% of total) in Slovak Republic in 2004 to that in 2005?
Ensure brevity in your answer.  1.05. What is the ratio of the Electricity production(% of total) of South Africa in 2004 to that in 2005?
Keep it short and to the point. 0.99. What is the ratio of the Electricity production(% of total) of Estonia in 2004 to that in 2006?
Give a very brief answer. 0.77. What is the ratio of the Electricity production(% of total) in Slovak Republic in 2004 to that in 2006?
Make the answer very short. 1.1. What is the ratio of the Electricity production(% of total) of South Africa in 2004 to that in 2006?
Provide a short and direct response. 0.99. What is the ratio of the Electricity production(% of total) of Estonia in 2004 to that in 2007?
Provide a short and direct response. 0.95. What is the ratio of the Electricity production(% of total) in Serbia in 2004 to that in 2007?
Your answer should be compact. 0.97. What is the ratio of the Electricity production(% of total) in Slovak Republic in 2004 to that in 2007?
Your answer should be compact. 1.07. What is the ratio of the Electricity production(% of total) of Estonia in 2004 to that in 2008?
Give a very brief answer. 0.73. What is the ratio of the Electricity production(% of total) of Serbia in 2004 to that in 2008?
Give a very brief answer. 0.94. What is the ratio of the Electricity production(% of total) of Slovak Republic in 2004 to that in 2008?
Your answer should be very brief. 1.12. What is the ratio of the Electricity production(% of total) in Estonia in 2004 to that in 2009?
Provide a succinct answer. 0.42. What is the ratio of the Electricity production(% of total) of Serbia in 2004 to that in 2009?
Keep it short and to the point. 0.96. What is the ratio of the Electricity production(% of total) in Slovak Republic in 2004 to that in 2009?
Offer a very short reply. 1.22. What is the ratio of the Electricity production(% of total) of South Africa in 2004 to that in 2009?
Ensure brevity in your answer.  1. What is the ratio of the Electricity production(% of total) in Estonia in 2004 to that in 2010?
Your answer should be compact. 0.61. What is the ratio of the Electricity production(% of total) of Serbia in 2004 to that in 2010?
Your response must be concise. 1.02. What is the ratio of the Electricity production(% of total) of Slovak Republic in 2004 to that in 2010?
Provide a short and direct response. 1.35. What is the ratio of the Electricity production(% of total) in South Africa in 2004 to that in 2010?
Offer a terse response. 1. What is the ratio of the Electricity production(% of total) of Estonia in 2005 to that in 2006?
Offer a very short reply. 0.84. What is the ratio of the Electricity production(% of total) in Serbia in 2005 to that in 2006?
Provide a short and direct response. 0.94. What is the ratio of the Electricity production(% of total) of Slovak Republic in 2005 to that in 2006?
Your answer should be compact. 1.04. What is the ratio of the Electricity production(% of total) of South Africa in 2005 to that in 2006?
Your answer should be compact. 1. What is the ratio of the Electricity production(% of total) in Estonia in 2005 to that in 2007?
Keep it short and to the point. 1.05. What is the ratio of the Electricity production(% of total) of Serbia in 2005 to that in 2007?
Your answer should be compact. 0.92. What is the ratio of the Electricity production(% of total) of Slovak Republic in 2005 to that in 2007?
Your answer should be compact. 1.02. What is the ratio of the Electricity production(% of total) of Estonia in 2005 to that in 2008?
Keep it short and to the point. 0.8. What is the ratio of the Electricity production(% of total) of Serbia in 2005 to that in 2008?
Ensure brevity in your answer.  0.89. What is the ratio of the Electricity production(% of total) of Slovak Republic in 2005 to that in 2008?
Keep it short and to the point. 1.07. What is the ratio of the Electricity production(% of total) of South Africa in 2005 to that in 2008?
Keep it short and to the point. 1. What is the ratio of the Electricity production(% of total) of Estonia in 2005 to that in 2009?
Give a very brief answer. 0.47. What is the ratio of the Electricity production(% of total) in Serbia in 2005 to that in 2009?
Provide a succinct answer. 0.9. What is the ratio of the Electricity production(% of total) in Slovak Republic in 2005 to that in 2009?
Ensure brevity in your answer.  1.16. What is the ratio of the Electricity production(% of total) of South Africa in 2005 to that in 2009?
Your response must be concise. 1.01. What is the ratio of the Electricity production(% of total) of Estonia in 2005 to that in 2010?
Ensure brevity in your answer.  0.67. What is the ratio of the Electricity production(% of total) in Serbia in 2005 to that in 2010?
Give a very brief answer. 0.96. What is the ratio of the Electricity production(% of total) of Slovak Republic in 2005 to that in 2010?
Your answer should be very brief. 1.28. What is the ratio of the Electricity production(% of total) in South Africa in 2005 to that in 2010?
Provide a succinct answer. 1. What is the ratio of the Electricity production(% of total) in Estonia in 2006 to that in 2007?
Offer a terse response. 1.24. What is the ratio of the Electricity production(% of total) of Serbia in 2006 to that in 2007?
Provide a succinct answer. 0.98. What is the ratio of the Electricity production(% of total) of Slovak Republic in 2006 to that in 2007?
Your answer should be compact. 0.98. What is the ratio of the Electricity production(% of total) in South Africa in 2006 to that in 2007?
Keep it short and to the point. 1. What is the ratio of the Electricity production(% of total) of Estonia in 2006 to that in 2008?
Your answer should be compact. 0.95. What is the ratio of the Electricity production(% of total) of Serbia in 2006 to that in 2008?
Offer a terse response. 0.95. What is the ratio of the Electricity production(% of total) of Slovak Republic in 2006 to that in 2008?
Your answer should be compact. 1.02. What is the ratio of the Electricity production(% of total) in South Africa in 2006 to that in 2008?
Your answer should be very brief. 1. What is the ratio of the Electricity production(% of total) of Estonia in 2006 to that in 2009?
Offer a terse response. 0.55. What is the ratio of the Electricity production(% of total) of Serbia in 2006 to that in 2009?
Offer a very short reply. 0.96. What is the ratio of the Electricity production(% of total) of Slovak Republic in 2006 to that in 2009?
Make the answer very short. 1.11. What is the ratio of the Electricity production(% of total) in Estonia in 2006 to that in 2010?
Provide a succinct answer. 0.79. What is the ratio of the Electricity production(% of total) of Serbia in 2006 to that in 2010?
Offer a terse response. 1.02. What is the ratio of the Electricity production(% of total) in Slovak Republic in 2006 to that in 2010?
Offer a very short reply. 1.23. What is the ratio of the Electricity production(% of total) of South Africa in 2006 to that in 2010?
Offer a very short reply. 1. What is the ratio of the Electricity production(% of total) in Estonia in 2007 to that in 2008?
Ensure brevity in your answer.  0.77. What is the ratio of the Electricity production(% of total) in Slovak Republic in 2007 to that in 2008?
Ensure brevity in your answer.  1.05. What is the ratio of the Electricity production(% of total) of South Africa in 2007 to that in 2008?
Keep it short and to the point. 1.01. What is the ratio of the Electricity production(% of total) of Estonia in 2007 to that in 2009?
Ensure brevity in your answer.  0.45. What is the ratio of the Electricity production(% of total) of Serbia in 2007 to that in 2009?
Keep it short and to the point. 0.98. What is the ratio of the Electricity production(% of total) of Slovak Republic in 2007 to that in 2009?
Your answer should be compact. 1.14. What is the ratio of the Electricity production(% of total) of South Africa in 2007 to that in 2009?
Your answer should be compact. 1.01. What is the ratio of the Electricity production(% of total) in Estonia in 2007 to that in 2010?
Offer a very short reply. 0.64. What is the ratio of the Electricity production(% of total) of Serbia in 2007 to that in 2010?
Your answer should be compact. 1.04. What is the ratio of the Electricity production(% of total) in Slovak Republic in 2007 to that in 2010?
Make the answer very short. 1.26. What is the ratio of the Electricity production(% of total) in South Africa in 2007 to that in 2010?
Provide a succinct answer. 1.01. What is the ratio of the Electricity production(% of total) of Estonia in 2008 to that in 2009?
Your answer should be very brief. 0.58. What is the ratio of the Electricity production(% of total) in Serbia in 2008 to that in 2009?
Your response must be concise. 1.02. What is the ratio of the Electricity production(% of total) of Slovak Republic in 2008 to that in 2009?
Make the answer very short. 1.09. What is the ratio of the Electricity production(% of total) in Estonia in 2008 to that in 2010?
Your answer should be compact. 0.84. What is the ratio of the Electricity production(% of total) in Serbia in 2008 to that in 2010?
Your answer should be very brief. 1.08. What is the ratio of the Electricity production(% of total) of Slovak Republic in 2008 to that in 2010?
Keep it short and to the point. 1.21. What is the ratio of the Electricity production(% of total) in South Africa in 2008 to that in 2010?
Provide a succinct answer. 1. What is the ratio of the Electricity production(% of total) of Estonia in 2009 to that in 2010?
Offer a terse response. 1.44. What is the ratio of the Electricity production(% of total) of Serbia in 2009 to that in 2010?
Your response must be concise. 1.06. What is the ratio of the Electricity production(% of total) of Slovak Republic in 2009 to that in 2010?
Your answer should be very brief. 1.11. What is the difference between the highest and the second highest Electricity production(% of total) of Estonia?
Your response must be concise. 1.38. What is the difference between the highest and the second highest Electricity production(% of total) in Serbia?
Make the answer very short. 1.12. What is the difference between the highest and the second highest Electricity production(% of total) in Slovak Republic?
Offer a very short reply. 1. What is the difference between the highest and the second highest Electricity production(% of total) of South Africa?
Your response must be concise. 0.06. What is the difference between the highest and the lowest Electricity production(% of total) in Estonia?
Offer a very short reply. 2.61. What is the difference between the highest and the lowest Electricity production(% of total) in Serbia?
Make the answer very short. 8.17. What is the difference between the highest and the lowest Electricity production(% of total) of Slovak Republic?
Provide a succinct answer. 5.22. What is the difference between the highest and the lowest Electricity production(% of total) in South Africa?
Your response must be concise. 0.83. 